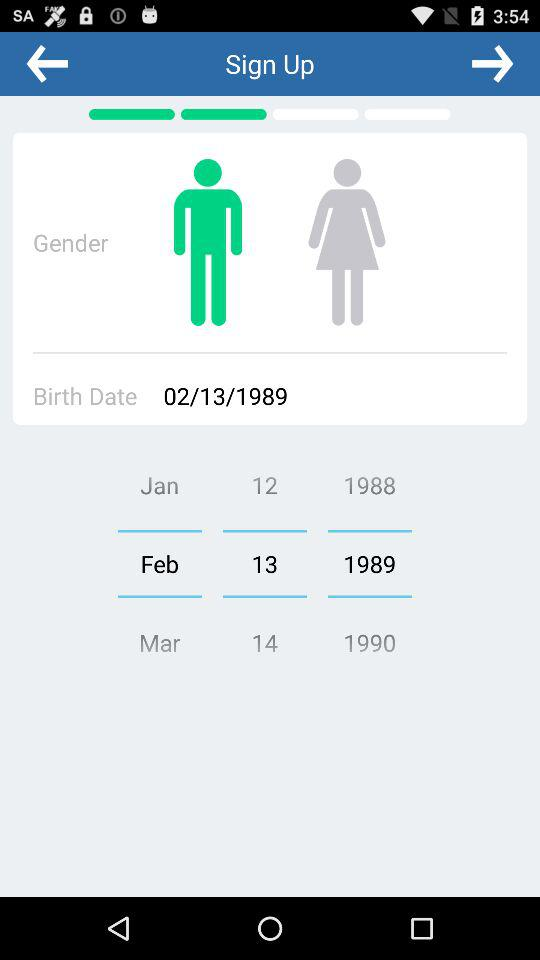How many months are available to select?
Answer the question using a single word or phrase. 12 